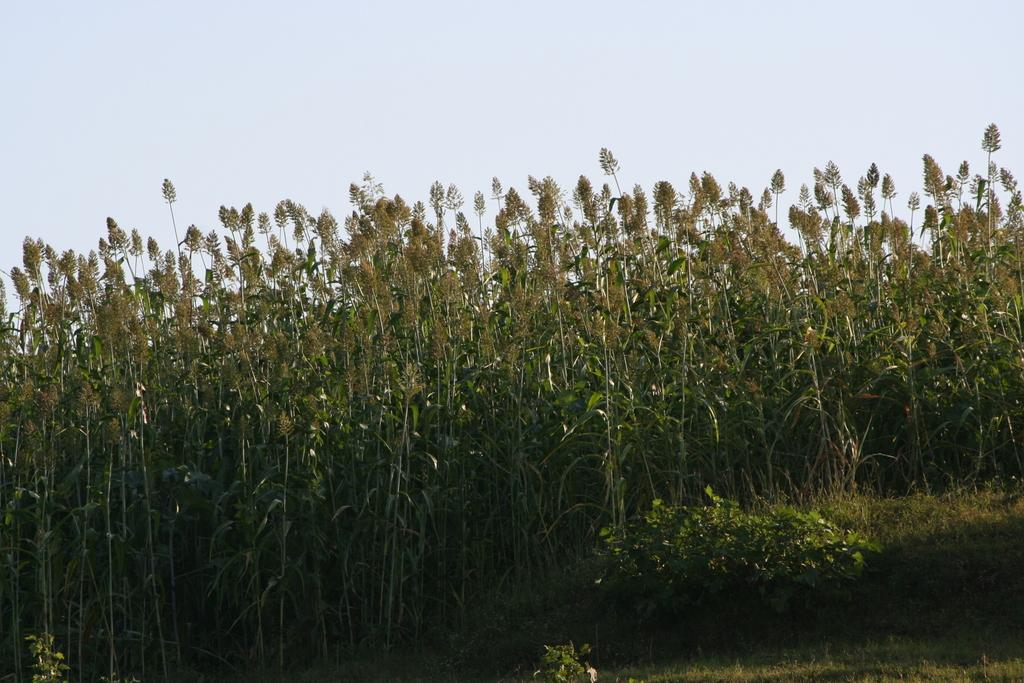What type of vegetation can be seen in the image? There are trees in the image. What colors are the trees in the image? The trees are green and brown in color. What else is present in the image besides trees? There is grass in the image. What can be seen in the background of the image? The sky is visible in the background of the image. What type of cent is visible in the image? There is no cent present in the image; it features trees, grass, and the sky. What type of scale can be seen in the image? There is no scale present in the image; it features trees, grass, and the sky. 